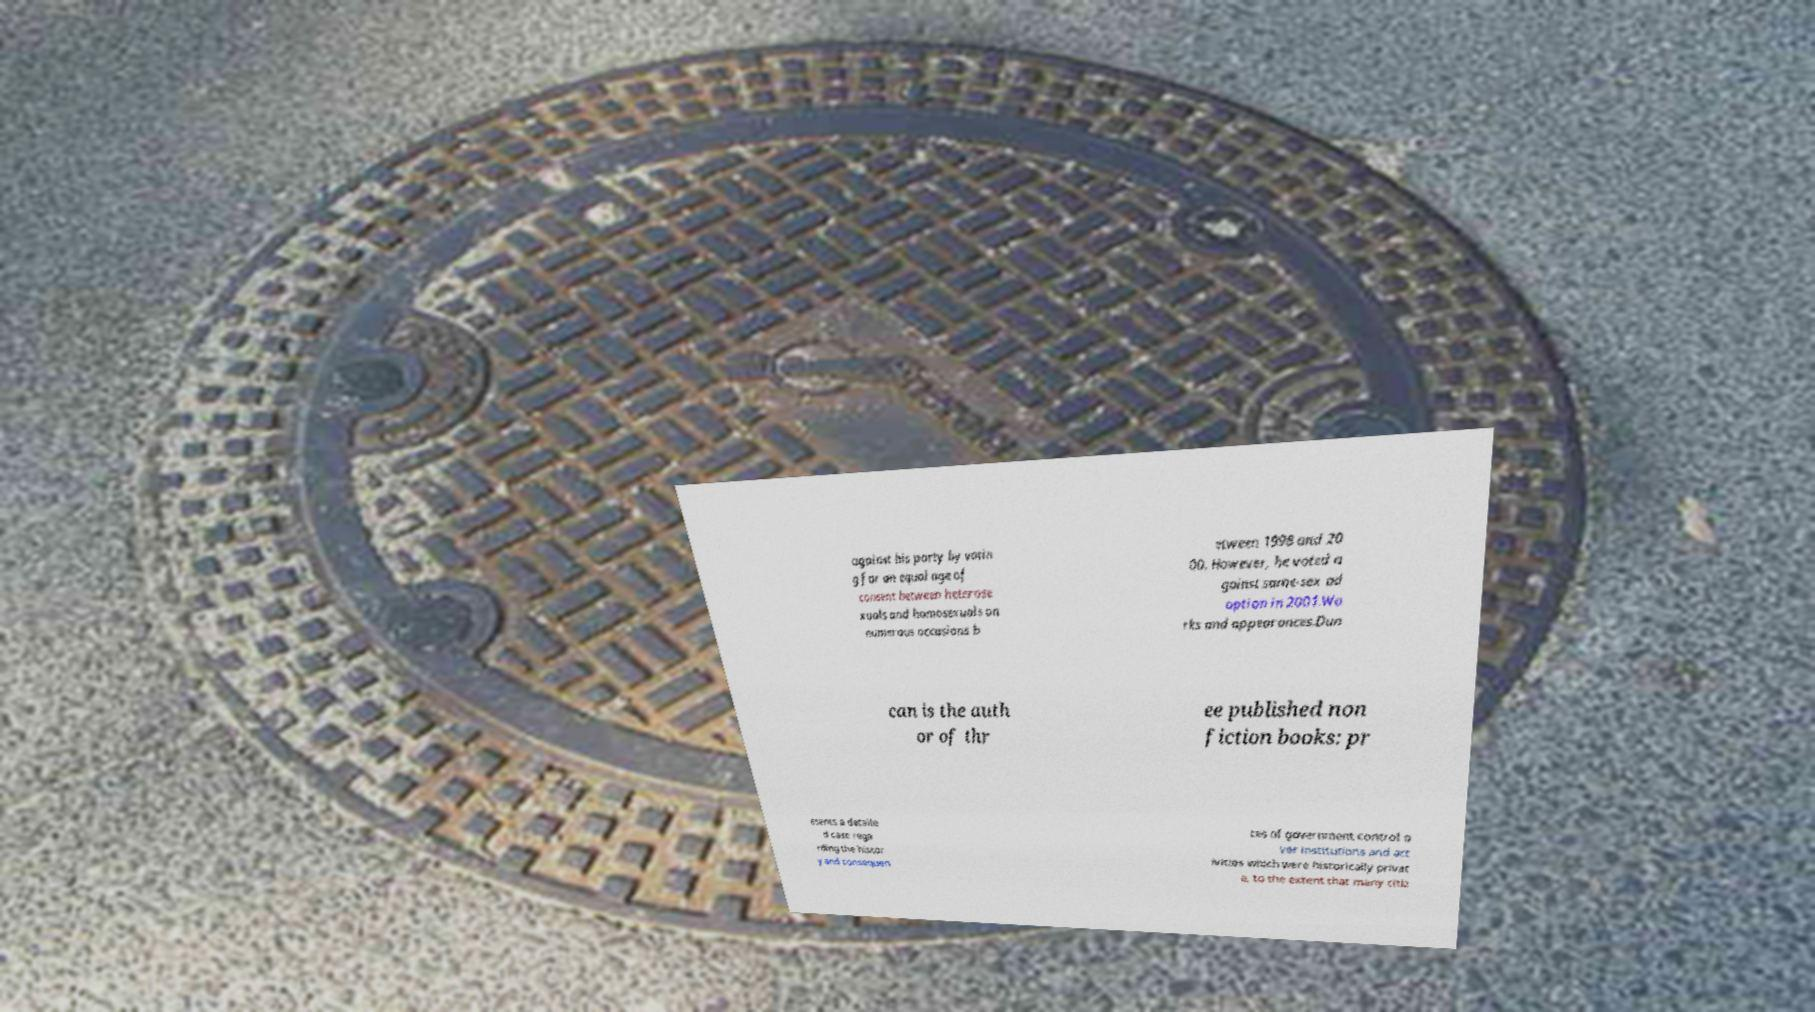For documentation purposes, I need the text within this image transcribed. Could you provide that? against his party by votin g for an equal age of consent between heterose xuals and homosexuals on numerous occasions b etween 1998 and 20 00. However, he voted a gainst same-sex ad option in 2001.Wo rks and appearances.Dun can is the auth or of thr ee published non fiction books: pr esents a detaile d case rega rding the histor y and consequen ces of government control o ver institutions and act ivities which were historically privat e, to the extent that many citiz 